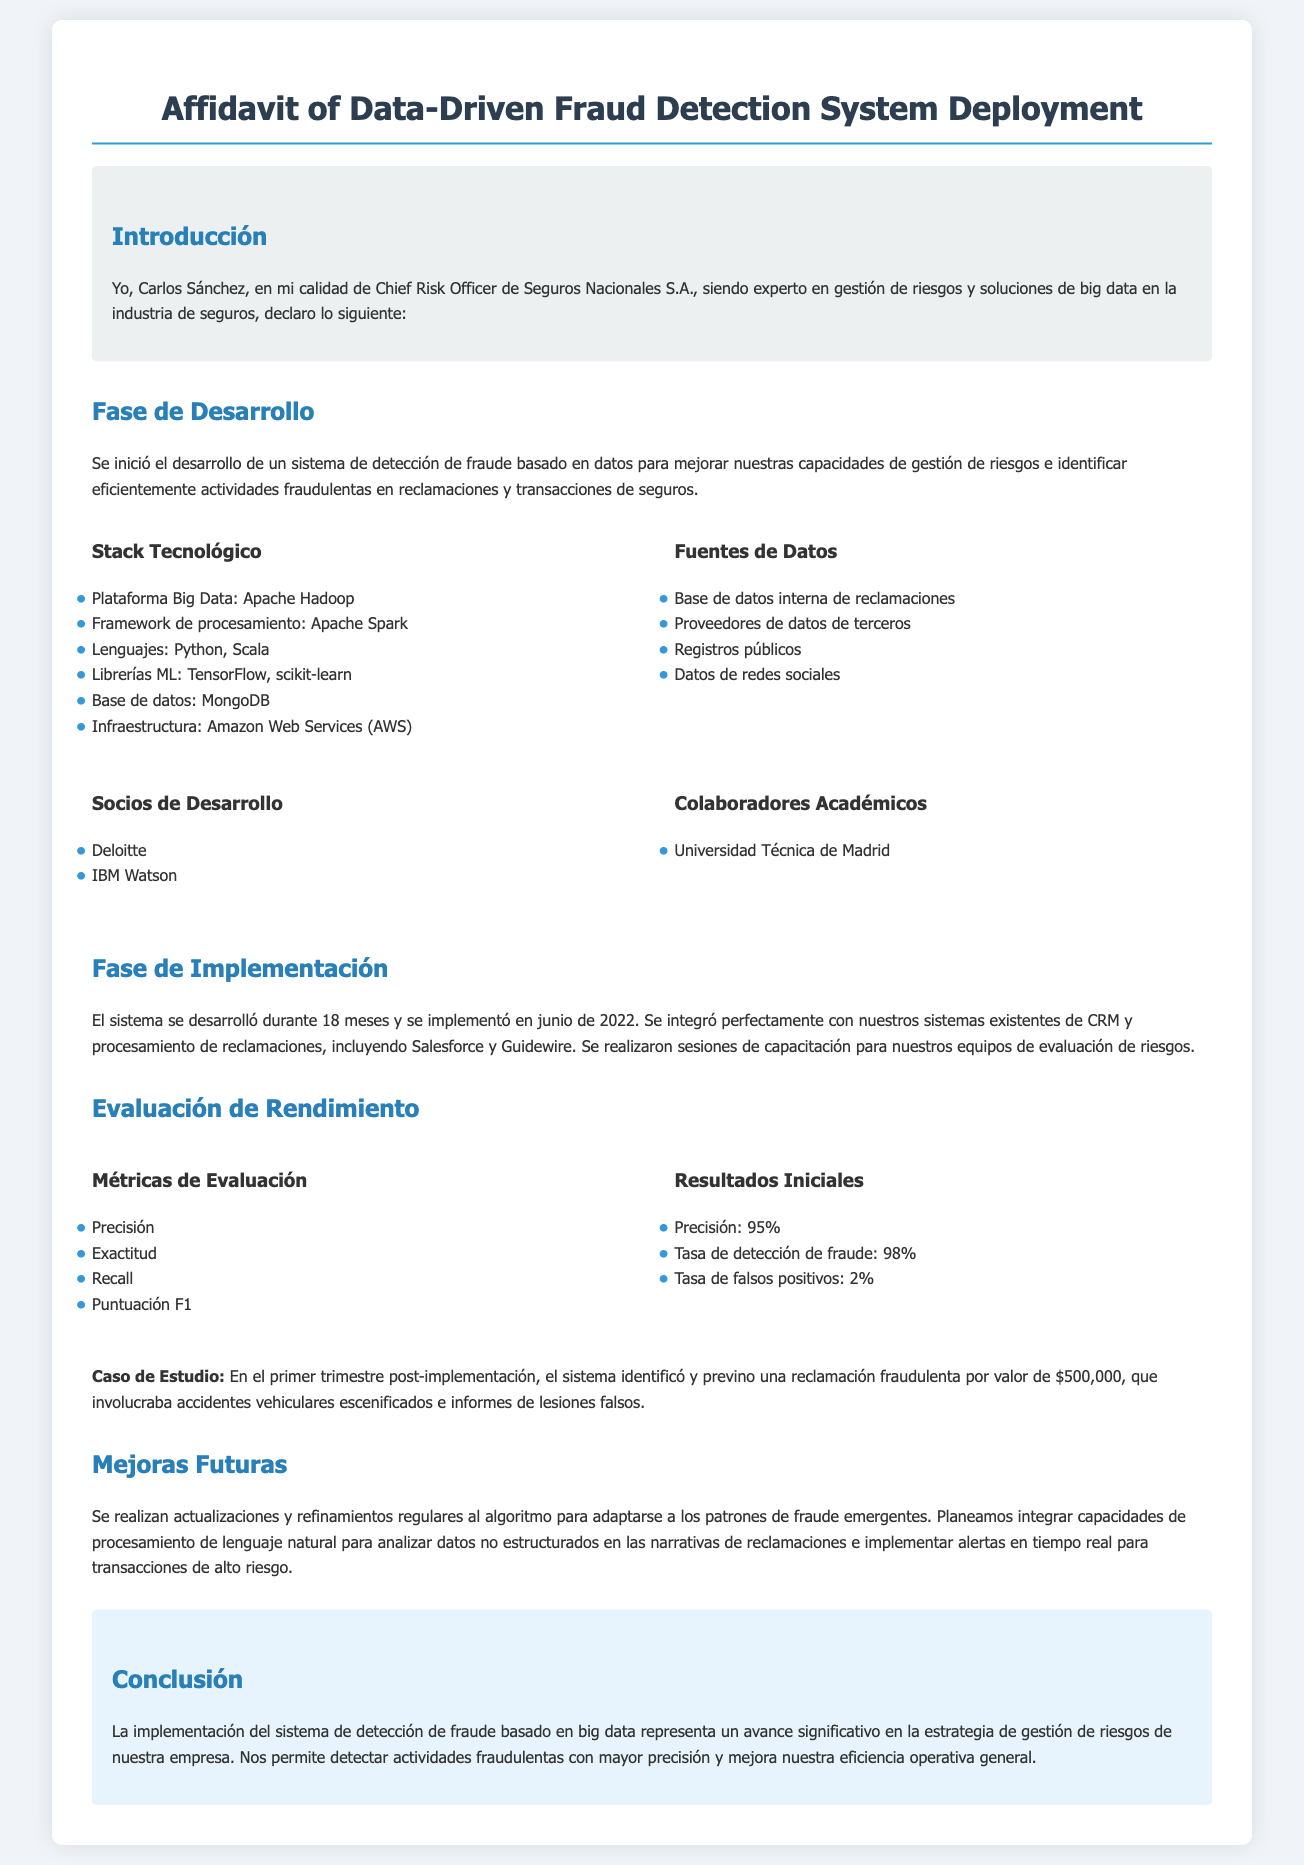¿Qué es el nombre del testigo? El testigo se identifica como Carlos Sánchez en el documento.
Answer: Carlos Sánchez ¿Cuál es la duración del desarrollo del sistema? La duración del desarrollo del sistema fue de 18 meses, según el documento.
Answer: 18 meses ¿Qué porcentaje de precisión reportó el sistema? El sistema reportó una precisión del 95%, como se indica en la sección de resultados.
Answer: 95% ¿Qué tecnología se utilizó para la base de datos? La tecnología de base de datos utilizada es MongoDB, mencionada en el stack tecnológico.
Answer: MongoDB ¿Cuál fue la tasa de detección de fraude? La tasa de detección de fraude reportada fue del 98%.
Answer: 98% ¿Cuál fue el valor de la reclamación fraudulenta identificada? La reclamación fraudulenta identificada tenía un valor de $500,000, como se menciona en el caso de estudio.
Answer: $500,000 ¿Qué bibliotecas de machine learning se usaron? Se mencionan TensorFlow y scikit-learn como las bibliotecas de machine learning en el stack tecnológico.
Answer: TensorFlow, scikit-learn ¿Quiénes fueron los socios de desarrollo? Los socios de desarrollo mencionados son Deloitte e IBM Watson.
Answer: Deloitte, IBM Watson ¿Qué se planea integrar para analizar datos no estructurados? Se planea integrar capacidades de procesamiento de lenguaje natural para analizar los datos no estructurados.
Answer: Procesamiento de lenguaje natural 